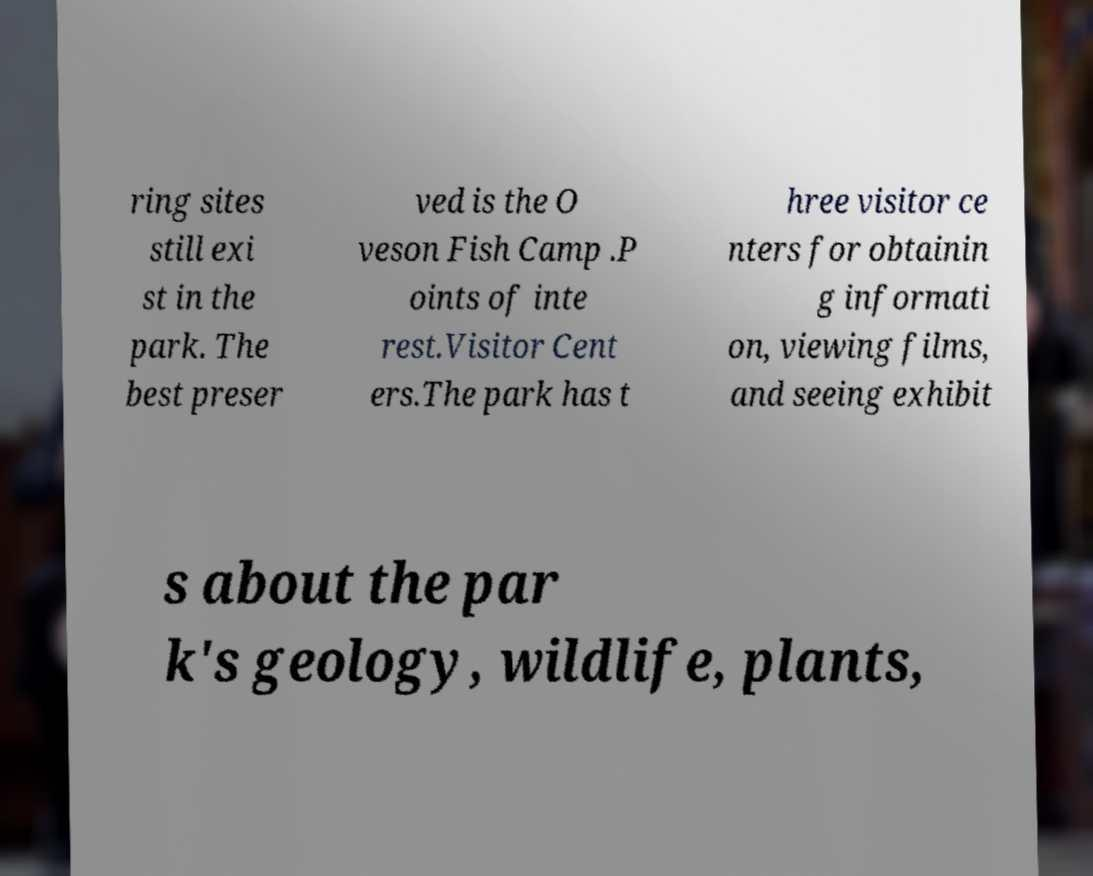Can you read and provide the text displayed in the image?This photo seems to have some interesting text. Can you extract and type it out for me? ring sites still exi st in the park. The best preser ved is the O veson Fish Camp .P oints of inte rest.Visitor Cent ers.The park has t hree visitor ce nters for obtainin g informati on, viewing films, and seeing exhibit s about the par k's geology, wildlife, plants, 